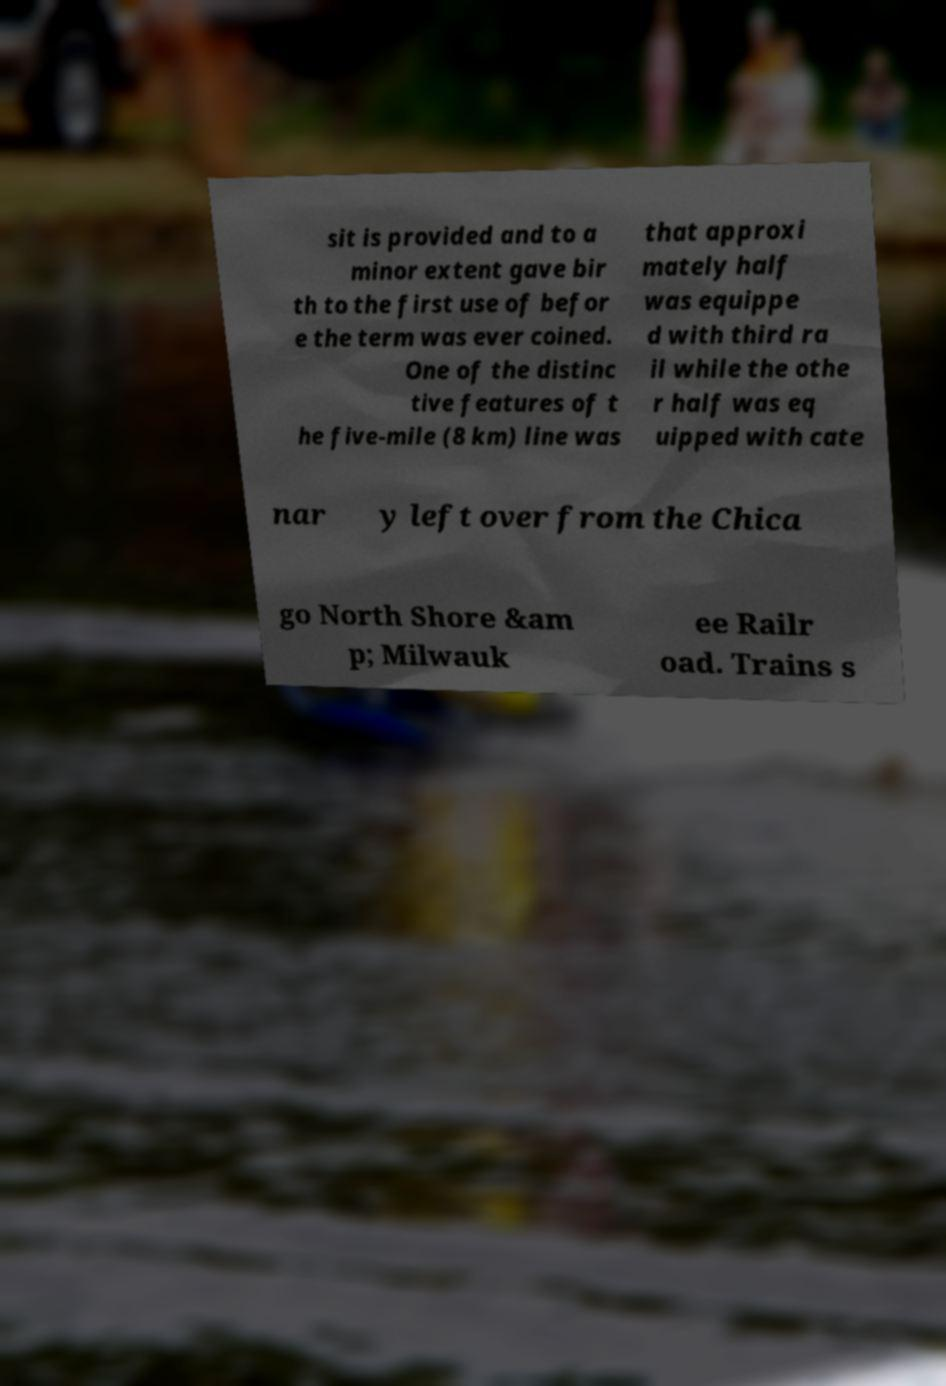Please identify and transcribe the text found in this image. sit is provided and to a minor extent gave bir th to the first use of befor e the term was ever coined. One of the distinc tive features of t he five-mile (8 km) line was that approxi mately half was equippe d with third ra il while the othe r half was eq uipped with cate nar y left over from the Chica go North Shore &am p; Milwauk ee Railr oad. Trains s 